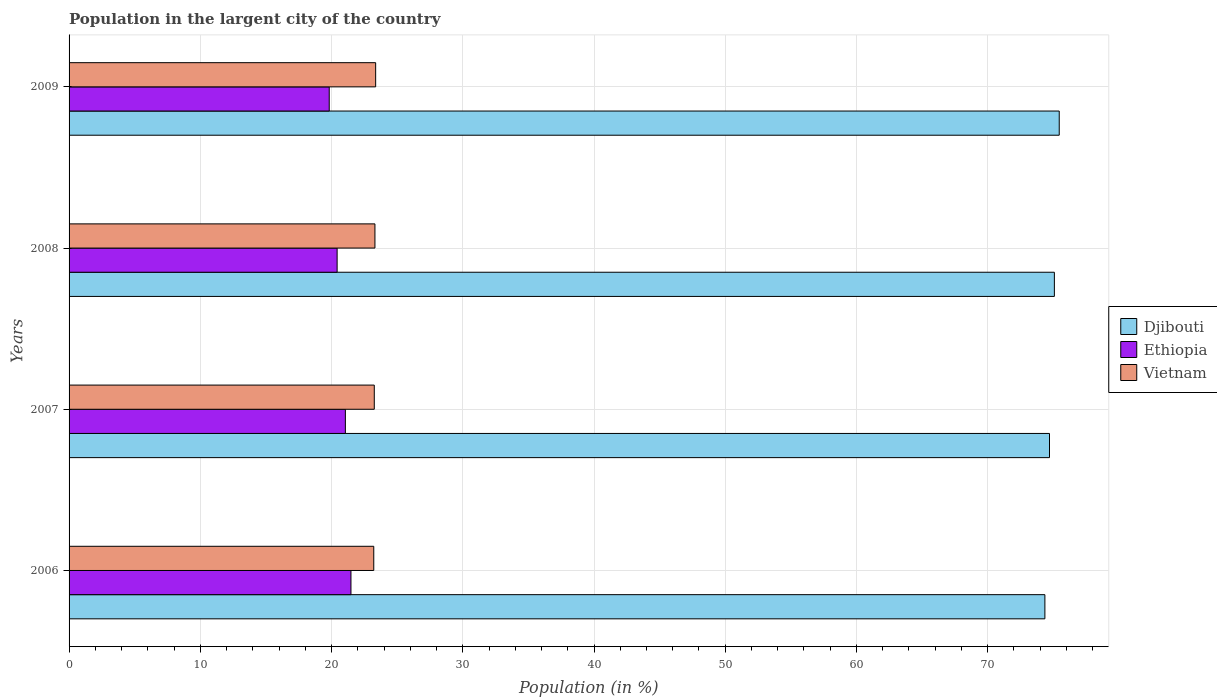How many groups of bars are there?
Keep it short and to the point. 4. What is the percentage of population in the largent city in Vietnam in 2009?
Your response must be concise. 23.36. Across all years, what is the maximum percentage of population in the largent city in Ethiopia?
Your response must be concise. 21.48. Across all years, what is the minimum percentage of population in the largent city in Ethiopia?
Your answer should be very brief. 19.82. In which year was the percentage of population in the largent city in Vietnam maximum?
Offer a very short reply. 2009. What is the total percentage of population in the largent city in Ethiopia in the graph?
Offer a very short reply. 82.78. What is the difference between the percentage of population in the largent city in Ethiopia in 2007 and that in 2009?
Keep it short and to the point. 1.23. What is the difference between the percentage of population in the largent city in Ethiopia in 2009 and the percentage of population in the largent city in Djibouti in 2007?
Provide a succinct answer. -54.89. What is the average percentage of population in the largent city in Vietnam per year?
Ensure brevity in your answer.  23.29. In the year 2007, what is the difference between the percentage of population in the largent city in Djibouti and percentage of population in the largent city in Vietnam?
Offer a terse response. 51.45. What is the ratio of the percentage of population in the largent city in Djibouti in 2008 to that in 2009?
Provide a short and direct response. 1. Is the percentage of population in the largent city in Ethiopia in 2008 less than that in 2009?
Your answer should be compact. No. Is the difference between the percentage of population in the largent city in Djibouti in 2006 and 2007 greater than the difference between the percentage of population in the largent city in Vietnam in 2006 and 2007?
Provide a short and direct response. No. What is the difference between the highest and the second highest percentage of population in the largent city in Djibouti?
Give a very brief answer. 0.37. What is the difference between the highest and the lowest percentage of population in the largent city in Djibouti?
Give a very brief answer. 1.09. In how many years, is the percentage of population in the largent city in Ethiopia greater than the average percentage of population in the largent city in Ethiopia taken over all years?
Your answer should be very brief. 2. What does the 3rd bar from the top in 2007 represents?
Provide a short and direct response. Djibouti. What does the 2nd bar from the bottom in 2009 represents?
Keep it short and to the point. Ethiopia. How many years are there in the graph?
Provide a succinct answer. 4. Are the values on the major ticks of X-axis written in scientific E-notation?
Your response must be concise. No. Does the graph contain any zero values?
Keep it short and to the point. No. Where does the legend appear in the graph?
Offer a very short reply. Center right. How many legend labels are there?
Your answer should be compact. 3. How are the legend labels stacked?
Give a very brief answer. Vertical. What is the title of the graph?
Offer a terse response. Population in the largent city of the country. What is the label or title of the X-axis?
Your answer should be compact. Population (in %). What is the label or title of the Y-axis?
Make the answer very short. Years. What is the Population (in %) in Djibouti in 2006?
Ensure brevity in your answer.  74.36. What is the Population (in %) in Ethiopia in 2006?
Keep it short and to the point. 21.48. What is the Population (in %) of Vietnam in 2006?
Keep it short and to the point. 23.22. What is the Population (in %) of Djibouti in 2007?
Make the answer very short. 74.71. What is the Population (in %) in Ethiopia in 2007?
Keep it short and to the point. 21.05. What is the Population (in %) of Vietnam in 2007?
Make the answer very short. 23.26. What is the Population (in %) of Djibouti in 2008?
Keep it short and to the point. 75.08. What is the Population (in %) of Ethiopia in 2008?
Make the answer very short. 20.43. What is the Population (in %) of Vietnam in 2008?
Keep it short and to the point. 23.31. What is the Population (in %) in Djibouti in 2009?
Provide a succinct answer. 75.45. What is the Population (in %) of Ethiopia in 2009?
Provide a succinct answer. 19.82. What is the Population (in %) in Vietnam in 2009?
Give a very brief answer. 23.36. Across all years, what is the maximum Population (in %) of Djibouti?
Keep it short and to the point. 75.45. Across all years, what is the maximum Population (in %) of Ethiopia?
Offer a very short reply. 21.48. Across all years, what is the maximum Population (in %) of Vietnam?
Keep it short and to the point. 23.36. Across all years, what is the minimum Population (in %) of Djibouti?
Your answer should be compact. 74.36. Across all years, what is the minimum Population (in %) in Ethiopia?
Keep it short and to the point. 19.82. Across all years, what is the minimum Population (in %) of Vietnam?
Your answer should be very brief. 23.22. What is the total Population (in %) in Djibouti in the graph?
Offer a terse response. 299.6. What is the total Population (in %) of Ethiopia in the graph?
Provide a short and direct response. 82.78. What is the total Population (in %) in Vietnam in the graph?
Offer a very short reply. 93.15. What is the difference between the Population (in %) of Djibouti in 2006 and that in 2007?
Provide a short and direct response. -0.35. What is the difference between the Population (in %) in Ethiopia in 2006 and that in 2007?
Make the answer very short. 0.43. What is the difference between the Population (in %) in Vietnam in 2006 and that in 2007?
Offer a very short reply. -0.04. What is the difference between the Population (in %) of Djibouti in 2006 and that in 2008?
Offer a very short reply. -0.72. What is the difference between the Population (in %) of Ethiopia in 2006 and that in 2008?
Make the answer very short. 1.05. What is the difference between the Population (in %) of Vietnam in 2006 and that in 2008?
Give a very brief answer. -0.09. What is the difference between the Population (in %) in Djibouti in 2006 and that in 2009?
Offer a very short reply. -1.09. What is the difference between the Population (in %) of Ethiopia in 2006 and that in 2009?
Your answer should be very brief. 1.66. What is the difference between the Population (in %) of Vietnam in 2006 and that in 2009?
Offer a very short reply. -0.14. What is the difference between the Population (in %) in Djibouti in 2007 and that in 2008?
Offer a terse response. -0.37. What is the difference between the Population (in %) in Ethiopia in 2007 and that in 2008?
Give a very brief answer. 0.63. What is the difference between the Population (in %) of Vietnam in 2007 and that in 2008?
Your answer should be compact. -0.05. What is the difference between the Population (in %) of Djibouti in 2007 and that in 2009?
Provide a short and direct response. -0.74. What is the difference between the Population (in %) in Ethiopia in 2007 and that in 2009?
Your answer should be very brief. 1.23. What is the difference between the Population (in %) in Vietnam in 2007 and that in 2009?
Offer a very short reply. -0.1. What is the difference between the Population (in %) of Djibouti in 2008 and that in 2009?
Offer a terse response. -0.37. What is the difference between the Population (in %) of Ethiopia in 2008 and that in 2009?
Provide a short and direct response. 0.6. What is the difference between the Population (in %) of Vietnam in 2008 and that in 2009?
Your answer should be very brief. -0.05. What is the difference between the Population (in %) of Djibouti in 2006 and the Population (in %) of Ethiopia in 2007?
Give a very brief answer. 53.3. What is the difference between the Population (in %) of Djibouti in 2006 and the Population (in %) of Vietnam in 2007?
Provide a short and direct response. 51.1. What is the difference between the Population (in %) in Ethiopia in 2006 and the Population (in %) in Vietnam in 2007?
Keep it short and to the point. -1.78. What is the difference between the Population (in %) in Djibouti in 2006 and the Population (in %) in Ethiopia in 2008?
Offer a terse response. 53.93. What is the difference between the Population (in %) of Djibouti in 2006 and the Population (in %) of Vietnam in 2008?
Your answer should be very brief. 51.05. What is the difference between the Population (in %) in Ethiopia in 2006 and the Population (in %) in Vietnam in 2008?
Give a very brief answer. -1.83. What is the difference between the Population (in %) in Djibouti in 2006 and the Population (in %) in Ethiopia in 2009?
Ensure brevity in your answer.  54.53. What is the difference between the Population (in %) in Djibouti in 2006 and the Population (in %) in Vietnam in 2009?
Your response must be concise. 51. What is the difference between the Population (in %) in Ethiopia in 2006 and the Population (in %) in Vietnam in 2009?
Make the answer very short. -1.88. What is the difference between the Population (in %) of Djibouti in 2007 and the Population (in %) of Ethiopia in 2008?
Your response must be concise. 54.28. What is the difference between the Population (in %) in Djibouti in 2007 and the Population (in %) in Vietnam in 2008?
Offer a very short reply. 51.4. What is the difference between the Population (in %) in Ethiopia in 2007 and the Population (in %) in Vietnam in 2008?
Your answer should be very brief. -2.25. What is the difference between the Population (in %) in Djibouti in 2007 and the Population (in %) in Ethiopia in 2009?
Keep it short and to the point. 54.89. What is the difference between the Population (in %) of Djibouti in 2007 and the Population (in %) of Vietnam in 2009?
Provide a succinct answer. 51.35. What is the difference between the Population (in %) in Ethiopia in 2007 and the Population (in %) in Vietnam in 2009?
Your answer should be compact. -2.31. What is the difference between the Population (in %) in Djibouti in 2008 and the Population (in %) in Ethiopia in 2009?
Provide a short and direct response. 55.26. What is the difference between the Population (in %) of Djibouti in 2008 and the Population (in %) of Vietnam in 2009?
Your answer should be very brief. 51.72. What is the difference between the Population (in %) of Ethiopia in 2008 and the Population (in %) of Vietnam in 2009?
Keep it short and to the point. -2.94. What is the average Population (in %) of Djibouti per year?
Offer a terse response. 74.9. What is the average Population (in %) in Ethiopia per year?
Give a very brief answer. 20.7. What is the average Population (in %) in Vietnam per year?
Give a very brief answer. 23.29. In the year 2006, what is the difference between the Population (in %) of Djibouti and Population (in %) of Ethiopia?
Your response must be concise. 52.88. In the year 2006, what is the difference between the Population (in %) in Djibouti and Population (in %) in Vietnam?
Offer a terse response. 51.14. In the year 2006, what is the difference between the Population (in %) of Ethiopia and Population (in %) of Vietnam?
Offer a terse response. -1.74. In the year 2007, what is the difference between the Population (in %) in Djibouti and Population (in %) in Ethiopia?
Your answer should be very brief. 53.66. In the year 2007, what is the difference between the Population (in %) in Djibouti and Population (in %) in Vietnam?
Provide a short and direct response. 51.45. In the year 2007, what is the difference between the Population (in %) of Ethiopia and Population (in %) of Vietnam?
Give a very brief answer. -2.2. In the year 2008, what is the difference between the Population (in %) of Djibouti and Population (in %) of Ethiopia?
Your answer should be compact. 54.66. In the year 2008, what is the difference between the Population (in %) in Djibouti and Population (in %) in Vietnam?
Your answer should be compact. 51.77. In the year 2008, what is the difference between the Population (in %) of Ethiopia and Population (in %) of Vietnam?
Provide a succinct answer. -2.88. In the year 2009, what is the difference between the Population (in %) in Djibouti and Population (in %) in Ethiopia?
Your answer should be compact. 55.63. In the year 2009, what is the difference between the Population (in %) of Djibouti and Population (in %) of Vietnam?
Your answer should be compact. 52.09. In the year 2009, what is the difference between the Population (in %) in Ethiopia and Population (in %) in Vietnam?
Offer a very short reply. -3.54. What is the ratio of the Population (in %) of Djibouti in 2006 to that in 2007?
Make the answer very short. 1. What is the ratio of the Population (in %) of Ethiopia in 2006 to that in 2007?
Provide a succinct answer. 1.02. What is the ratio of the Population (in %) of Ethiopia in 2006 to that in 2008?
Your answer should be very brief. 1.05. What is the ratio of the Population (in %) of Vietnam in 2006 to that in 2008?
Keep it short and to the point. 1. What is the ratio of the Population (in %) of Djibouti in 2006 to that in 2009?
Give a very brief answer. 0.99. What is the ratio of the Population (in %) in Ethiopia in 2006 to that in 2009?
Your response must be concise. 1.08. What is the ratio of the Population (in %) in Vietnam in 2006 to that in 2009?
Make the answer very short. 0.99. What is the ratio of the Population (in %) of Ethiopia in 2007 to that in 2008?
Keep it short and to the point. 1.03. What is the ratio of the Population (in %) in Vietnam in 2007 to that in 2008?
Your response must be concise. 1. What is the ratio of the Population (in %) in Djibouti in 2007 to that in 2009?
Give a very brief answer. 0.99. What is the ratio of the Population (in %) of Ethiopia in 2007 to that in 2009?
Your answer should be compact. 1.06. What is the ratio of the Population (in %) of Vietnam in 2007 to that in 2009?
Keep it short and to the point. 1. What is the ratio of the Population (in %) in Djibouti in 2008 to that in 2009?
Provide a short and direct response. 1. What is the ratio of the Population (in %) in Ethiopia in 2008 to that in 2009?
Your answer should be compact. 1.03. What is the ratio of the Population (in %) in Vietnam in 2008 to that in 2009?
Offer a terse response. 1. What is the difference between the highest and the second highest Population (in %) of Djibouti?
Make the answer very short. 0.37. What is the difference between the highest and the second highest Population (in %) of Ethiopia?
Provide a succinct answer. 0.43. What is the difference between the highest and the second highest Population (in %) of Vietnam?
Your answer should be compact. 0.05. What is the difference between the highest and the lowest Population (in %) of Djibouti?
Provide a short and direct response. 1.09. What is the difference between the highest and the lowest Population (in %) of Ethiopia?
Ensure brevity in your answer.  1.66. What is the difference between the highest and the lowest Population (in %) of Vietnam?
Keep it short and to the point. 0.14. 